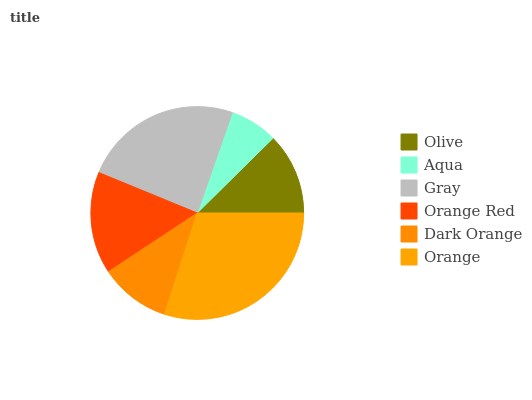Is Aqua the minimum?
Answer yes or no. Yes. Is Orange the maximum?
Answer yes or no. Yes. Is Gray the minimum?
Answer yes or no. No. Is Gray the maximum?
Answer yes or no. No. Is Gray greater than Aqua?
Answer yes or no. Yes. Is Aqua less than Gray?
Answer yes or no. Yes. Is Aqua greater than Gray?
Answer yes or no. No. Is Gray less than Aqua?
Answer yes or no. No. Is Orange Red the high median?
Answer yes or no. Yes. Is Olive the low median?
Answer yes or no. Yes. Is Orange the high median?
Answer yes or no. No. Is Gray the low median?
Answer yes or no. No. 